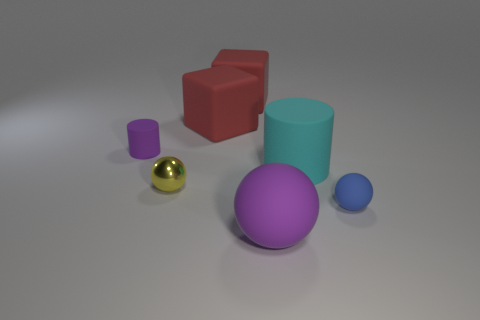What is the big thing that is both in front of the tiny matte cylinder and behind the big ball made of? The large object situated both in front of the small matte cylinder and behind the big glossy ball appears to be a cylinder as well and might be made of a material similar to plastic, given its smooth surface and the way it reflects light. 